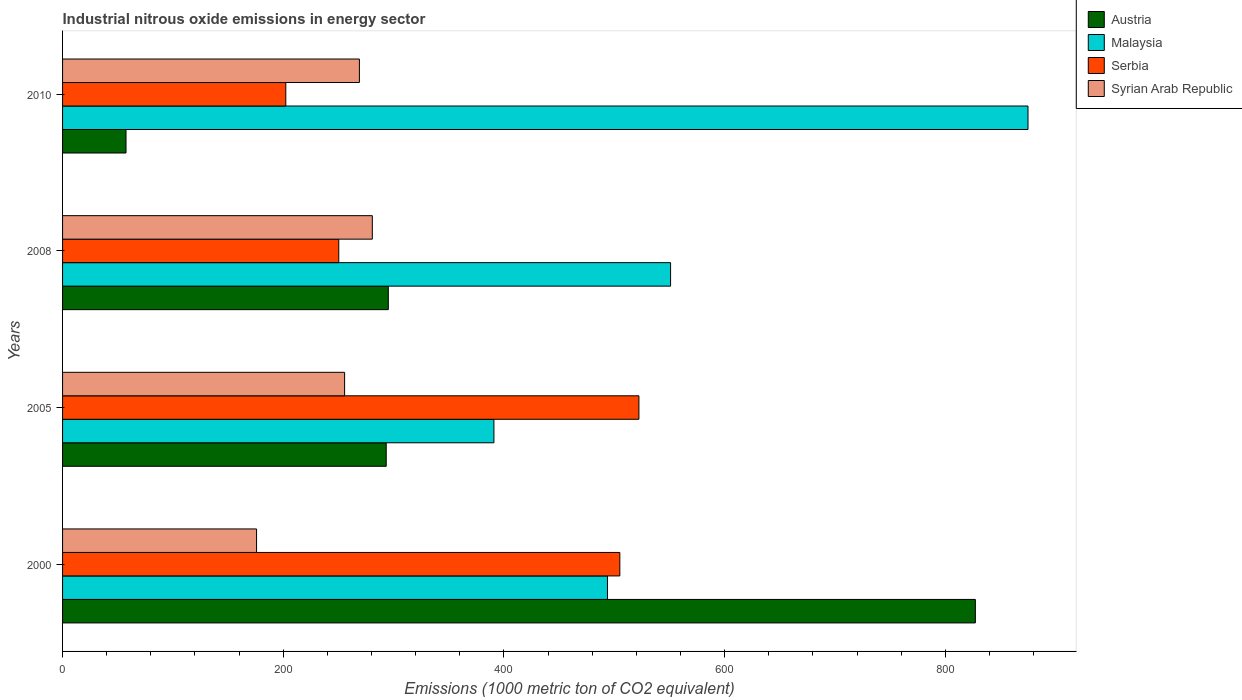How many different coloured bars are there?
Offer a terse response. 4. How many groups of bars are there?
Offer a terse response. 4. Are the number of bars on each tick of the Y-axis equal?
Your answer should be very brief. Yes. How many bars are there on the 4th tick from the top?
Provide a succinct answer. 4. What is the label of the 2nd group of bars from the top?
Offer a very short reply. 2008. In how many cases, is the number of bars for a given year not equal to the number of legend labels?
Your response must be concise. 0. What is the amount of industrial nitrous oxide emitted in Syrian Arab Republic in 2008?
Give a very brief answer. 280.7. Across all years, what is the maximum amount of industrial nitrous oxide emitted in Serbia?
Give a very brief answer. 522.3. Across all years, what is the minimum amount of industrial nitrous oxide emitted in Austria?
Give a very brief answer. 57.5. In which year was the amount of industrial nitrous oxide emitted in Syrian Arab Republic maximum?
Provide a succinct answer. 2008. In which year was the amount of industrial nitrous oxide emitted in Malaysia minimum?
Provide a short and direct response. 2005. What is the total amount of industrial nitrous oxide emitted in Serbia in the graph?
Provide a succinct answer. 1479.9. What is the difference between the amount of industrial nitrous oxide emitted in Malaysia in 2005 and that in 2008?
Keep it short and to the point. -160.1. What is the difference between the amount of industrial nitrous oxide emitted in Malaysia in 2000 and the amount of industrial nitrous oxide emitted in Syrian Arab Republic in 2008?
Offer a very short reply. 213.1. What is the average amount of industrial nitrous oxide emitted in Serbia per year?
Keep it short and to the point. 369.97. In the year 2000, what is the difference between the amount of industrial nitrous oxide emitted in Syrian Arab Republic and amount of industrial nitrous oxide emitted in Serbia?
Your answer should be very brief. -329.2. What is the ratio of the amount of industrial nitrous oxide emitted in Malaysia in 2005 to that in 2008?
Provide a short and direct response. 0.71. What is the difference between the highest and the second highest amount of industrial nitrous oxide emitted in Syrian Arab Republic?
Your answer should be compact. 11.7. What is the difference between the highest and the lowest amount of industrial nitrous oxide emitted in Syrian Arab Republic?
Provide a short and direct response. 104.9. In how many years, is the amount of industrial nitrous oxide emitted in Austria greater than the average amount of industrial nitrous oxide emitted in Austria taken over all years?
Offer a terse response. 1. What does the 2nd bar from the top in 2008 represents?
Ensure brevity in your answer.  Serbia. Is it the case that in every year, the sum of the amount of industrial nitrous oxide emitted in Austria and amount of industrial nitrous oxide emitted in Serbia is greater than the amount of industrial nitrous oxide emitted in Malaysia?
Offer a terse response. No. How many years are there in the graph?
Offer a very short reply. 4. What is the difference between two consecutive major ticks on the X-axis?
Your answer should be very brief. 200. Are the values on the major ticks of X-axis written in scientific E-notation?
Provide a succinct answer. No. Does the graph contain any zero values?
Provide a short and direct response. No. How are the legend labels stacked?
Keep it short and to the point. Vertical. What is the title of the graph?
Your answer should be compact. Industrial nitrous oxide emissions in energy sector. Does "Puerto Rico" appear as one of the legend labels in the graph?
Give a very brief answer. No. What is the label or title of the X-axis?
Make the answer very short. Emissions (1000 metric ton of CO2 equivalent). What is the Emissions (1000 metric ton of CO2 equivalent) in Austria in 2000?
Give a very brief answer. 827.2. What is the Emissions (1000 metric ton of CO2 equivalent) in Malaysia in 2000?
Your answer should be compact. 493.8. What is the Emissions (1000 metric ton of CO2 equivalent) in Serbia in 2000?
Provide a short and direct response. 505. What is the Emissions (1000 metric ton of CO2 equivalent) in Syrian Arab Republic in 2000?
Your answer should be compact. 175.8. What is the Emissions (1000 metric ton of CO2 equivalent) of Austria in 2005?
Keep it short and to the point. 293.3. What is the Emissions (1000 metric ton of CO2 equivalent) of Malaysia in 2005?
Your response must be concise. 390.9. What is the Emissions (1000 metric ton of CO2 equivalent) of Serbia in 2005?
Give a very brief answer. 522.3. What is the Emissions (1000 metric ton of CO2 equivalent) in Syrian Arab Republic in 2005?
Provide a succinct answer. 255.6. What is the Emissions (1000 metric ton of CO2 equivalent) of Austria in 2008?
Provide a succinct answer. 295.2. What is the Emissions (1000 metric ton of CO2 equivalent) of Malaysia in 2008?
Your answer should be very brief. 551. What is the Emissions (1000 metric ton of CO2 equivalent) of Serbia in 2008?
Your answer should be compact. 250.3. What is the Emissions (1000 metric ton of CO2 equivalent) in Syrian Arab Republic in 2008?
Keep it short and to the point. 280.7. What is the Emissions (1000 metric ton of CO2 equivalent) in Austria in 2010?
Your answer should be very brief. 57.5. What is the Emissions (1000 metric ton of CO2 equivalent) in Malaysia in 2010?
Provide a short and direct response. 874.9. What is the Emissions (1000 metric ton of CO2 equivalent) in Serbia in 2010?
Provide a short and direct response. 202.3. What is the Emissions (1000 metric ton of CO2 equivalent) of Syrian Arab Republic in 2010?
Your answer should be very brief. 269. Across all years, what is the maximum Emissions (1000 metric ton of CO2 equivalent) in Austria?
Give a very brief answer. 827.2. Across all years, what is the maximum Emissions (1000 metric ton of CO2 equivalent) of Malaysia?
Your answer should be very brief. 874.9. Across all years, what is the maximum Emissions (1000 metric ton of CO2 equivalent) of Serbia?
Ensure brevity in your answer.  522.3. Across all years, what is the maximum Emissions (1000 metric ton of CO2 equivalent) in Syrian Arab Republic?
Give a very brief answer. 280.7. Across all years, what is the minimum Emissions (1000 metric ton of CO2 equivalent) in Austria?
Make the answer very short. 57.5. Across all years, what is the minimum Emissions (1000 metric ton of CO2 equivalent) in Malaysia?
Provide a succinct answer. 390.9. Across all years, what is the minimum Emissions (1000 metric ton of CO2 equivalent) in Serbia?
Provide a short and direct response. 202.3. Across all years, what is the minimum Emissions (1000 metric ton of CO2 equivalent) in Syrian Arab Republic?
Provide a short and direct response. 175.8. What is the total Emissions (1000 metric ton of CO2 equivalent) of Austria in the graph?
Keep it short and to the point. 1473.2. What is the total Emissions (1000 metric ton of CO2 equivalent) in Malaysia in the graph?
Ensure brevity in your answer.  2310.6. What is the total Emissions (1000 metric ton of CO2 equivalent) in Serbia in the graph?
Provide a short and direct response. 1479.9. What is the total Emissions (1000 metric ton of CO2 equivalent) of Syrian Arab Republic in the graph?
Offer a very short reply. 981.1. What is the difference between the Emissions (1000 metric ton of CO2 equivalent) of Austria in 2000 and that in 2005?
Your answer should be compact. 533.9. What is the difference between the Emissions (1000 metric ton of CO2 equivalent) in Malaysia in 2000 and that in 2005?
Provide a short and direct response. 102.9. What is the difference between the Emissions (1000 metric ton of CO2 equivalent) of Serbia in 2000 and that in 2005?
Your answer should be very brief. -17.3. What is the difference between the Emissions (1000 metric ton of CO2 equivalent) in Syrian Arab Republic in 2000 and that in 2005?
Provide a succinct answer. -79.8. What is the difference between the Emissions (1000 metric ton of CO2 equivalent) in Austria in 2000 and that in 2008?
Offer a terse response. 532. What is the difference between the Emissions (1000 metric ton of CO2 equivalent) of Malaysia in 2000 and that in 2008?
Keep it short and to the point. -57.2. What is the difference between the Emissions (1000 metric ton of CO2 equivalent) in Serbia in 2000 and that in 2008?
Offer a terse response. 254.7. What is the difference between the Emissions (1000 metric ton of CO2 equivalent) in Syrian Arab Republic in 2000 and that in 2008?
Offer a terse response. -104.9. What is the difference between the Emissions (1000 metric ton of CO2 equivalent) in Austria in 2000 and that in 2010?
Provide a short and direct response. 769.7. What is the difference between the Emissions (1000 metric ton of CO2 equivalent) in Malaysia in 2000 and that in 2010?
Make the answer very short. -381.1. What is the difference between the Emissions (1000 metric ton of CO2 equivalent) of Serbia in 2000 and that in 2010?
Your answer should be compact. 302.7. What is the difference between the Emissions (1000 metric ton of CO2 equivalent) in Syrian Arab Republic in 2000 and that in 2010?
Your response must be concise. -93.2. What is the difference between the Emissions (1000 metric ton of CO2 equivalent) of Malaysia in 2005 and that in 2008?
Ensure brevity in your answer.  -160.1. What is the difference between the Emissions (1000 metric ton of CO2 equivalent) of Serbia in 2005 and that in 2008?
Provide a succinct answer. 272. What is the difference between the Emissions (1000 metric ton of CO2 equivalent) of Syrian Arab Republic in 2005 and that in 2008?
Provide a succinct answer. -25.1. What is the difference between the Emissions (1000 metric ton of CO2 equivalent) in Austria in 2005 and that in 2010?
Provide a short and direct response. 235.8. What is the difference between the Emissions (1000 metric ton of CO2 equivalent) of Malaysia in 2005 and that in 2010?
Ensure brevity in your answer.  -484. What is the difference between the Emissions (1000 metric ton of CO2 equivalent) of Serbia in 2005 and that in 2010?
Provide a succinct answer. 320. What is the difference between the Emissions (1000 metric ton of CO2 equivalent) of Austria in 2008 and that in 2010?
Keep it short and to the point. 237.7. What is the difference between the Emissions (1000 metric ton of CO2 equivalent) in Malaysia in 2008 and that in 2010?
Offer a terse response. -323.9. What is the difference between the Emissions (1000 metric ton of CO2 equivalent) in Syrian Arab Republic in 2008 and that in 2010?
Your response must be concise. 11.7. What is the difference between the Emissions (1000 metric ton of CO2 equivalent) of Austria in 2000 and the Emissions (1000 metric ton of CO2 equivalent) of Malaysia in 2005?
Offer a very short reply. 436.3. What is the difference between the Emissions (1000 metric ton of CO2 equivalent) in Austria in 2000 and the Emissions (1000 metric ton of CO2 equivalent) in Serbia in 2005?
Give a very brief answer. 304.9. What is the difference between the Emissions (1000 metric ton of CO2 equivalent) of Austria in 2000 and the Emissions (1000 metric ton of CO2 equivalent) of Syrian Arab Republic in 2005?
Keep it short and to the point. 571.6. What is the difference between the Emissions (1000 metric ton of CO2 equivalent) of Malaysia in 2000 and the Emissions (1000 metric ton of CO2 equivalent) of Serbia in 2005?
Provide a short and direct response. -28.5. What is the difference between the Emissions (1000 metric ton of CO2 equivalent) of Malaysia in 2000 and the Emissions (1000 metric ton of CO2 equivalent) of Syrian Arab Republic in 2005?
Your answer should be very brief. 238.2. What is the difference between the Emissions (1000 metric ton of CO2 equivalent) of Serbia in 2000 and the Emissions (1000 metric ton of CO2 equivalent) of Syrian Arab Republic in 2005?
Ensure brevity in your answer.  249.4. What is the difference between the Emissions (1000 metric ton of CO2 equivalent) of Austria in 2000 and the Emissions (1000 metric ton of CO2 equivalent) of Malaysia in 2008?
Provide a succinct answer. 276.2. What is the difference between the Emissions (1000 metric ton of CO2 equivalent) in Austria in 2000 and the Emissions (1000 metric ton of CO2 equivalent) in Serbia in 2008?
Offer a terse response. 576.9. What is the difference between the Emissions (1000 metric ton of CO2 equivalent) in Austria in 2000 and the Emissions (1000 metric ton of CO2 equivalent) in Syrian Arab Republic in 2008?
Your answer should be compact. 546.5. What is the difference between the Emissions (1000 metric ton of CO2 equivalent) in Malaysia in 2000 and the Emissions (1000 metric ton of CO2 equivalent) in Serbia in 2008?
Provide a short and direct response. 243.5. What is the difference between the Emissions (1000 metric ton of CO2 equivalent) in Malaysia in 2000 and the Emissions (1000 metric ton of CO2 equivalent) in Syrian Arab Republic in 2008?
Make the answer very short. 213.1. What is the difference between the Emissions (1000 metric ton of CO2 equivalent) in Serbia in 2000 and the Emissions (1000 metric ton of CO2 equivalent) in Syrian Arab Republic in 2008?
Provide a succinct answer. 224.3. What is the difference between the Emissions (1000 metric ton of CO2 equivalent) of Austria in 2000 and the Emissions (1000 metric ton of CO2 equivalent) of Malaysia in 2010?
Your response must be concise. -47.7. What is the difference between the Emissions (1000 metric ton of CO2 equivalent) in Austria in 2000 and the Emissions (1000 metric ton of CO2 equivalent) in Serbia in 2010?
Ensure brevity in your answer.  624.9. What is the difference between the Emissions (1000 metric ton of CO2 equivalent) of Austria in 2000 and the Emissions (1000 metric ton of CO2 equivalent) of Syrian Arab Republic in 2010?
Offer a terse response. 558.2. What is the difference between the Emissions (1000 metric ton of CO2 equivalent) in Malaysia in 2000 and the Emissions (1000 metric ton of CO2 equivalent) in Serbia in 2010?
Offer a very short reply. 291.5. What is the difference between the Emissions (1000 metric ton of CO2 equivalent) of Malaysia in 2000 and the Emissions (1000 metric ton of CO2 equivalent) of Syrian Arab Republic in 2010?
Keep it short and to the point. 224.8. What is the difference between the Emissions (1000 metric ton of CO2 equivalent) of Serbia in 2000 and the Emissions (1000 metric ton of CO2 equivalent) of Syrian Arab Republic in 2010?
Offer a terse response. 236. What is the difference between the Emissions (1000 metric ton of CO2 equivalent) of Austria in 2005 and the Emissions (1000 metric ton of CO2 equivalent) of Malaysia in 2008?
Your response must be concise. -257.7. What is the difference between the Emissions (1000 metric ton of CO2 equivalent) in Austria in 2005 and the Emissions (1000 metric ton of CO2 equivalent) in Syrian Arab Republic in 2008?
Provide a succinct answer. 12.6. What is the difference between the Emissions (1000 metric ton of CO2 equivalent) in Malaysia in 2005 and the Emissions (1000 metric ton of CO2 equivalent) in Serbia in 2008?
Make the answer very short. 140.6. What is the difference between the Emissions (1000 metric ton of CO2 equivalent) of Malaysia in 2005 and the Emissions (1000 metric ton of CO2 equivalent) of Syrian Arab Republic in 2008?
Provide a short and direct response. 110.2. What is the difference between the Emissions (1000 metric ton of CO2 equivalent) in Serbia in 2005 and the Emissions (1000 metric ton of CO2 equivalent) in Syrian Arab Republic in 2008?
Offer a terse response. 241.6. What is the difference between the Emissions (1000 metric ton of CO2 equivalent) of Austria in 2005 and the Emissions (1000 metric ton of CO2 equivalent) of Malaysia in 2010?
Offer a terse response. -581.6. What is the difference between the Emissions (1000 metric ton of CO2 equivalent) in Austria in 2005 and the Emissions (1000 metric ton of CO2 equivalent) in Serbia in 2010?
Your response must be concise. 91. What is the difference between the Emissions (1000 metric ton of CO2 equivalent) in Austria in 2005 and the Emissions (1000 metric ton of CO2 equivalent) in Syrian Arab Republic in 2010?
Give a very brief answer. 24.3. What is the difference between the Emissions (1000 metric ton of CO2 equivalent) in Malaysia in 2005 and the Emissions (1000 metric ton of CO2 equivalent) in Serbia in 2010?
Provide a short and direct response. 188.6. What is the difference between the Emissions (1000 metric ton of CO2 equivalent) in Malaysia in 2005 and the Emissions (1000 metric ton of CO2 equivalent) in Syrian Arab Republic in 2010?
Give a very brief answer. 121.9. What is the difference between the Emissions (1000 metric ton of CO2 equivalent) in Serbia in 2005 and the Emissions (1000 metric ton of CO2 equivalent) in Syrian Arab Republic in 2010?
Give a very brief answer. 253.3. What is the difference between the Emissions (1000 metric ton of CO2 equivalent) in Austria in 2008 and the Emissions (1000 metric ton of CO2 equivalent) in Malaysia in 2010?
Your response must be concise. -579.7. What is the difference between the Emissions (1000 metric ton of CO2 equivalent) of Austria in 2008 and the Emissions (1000 metric ton of CO2 equivalent) of Serbia in 2010?
Your answer should be compact. 92.9. What is the difference between the Emissions (1000 metric ton of CO2 equivalent) of Austria in 2008 and the Emissions (1000 metric ton of CO2 equivalent) of Syrian Arab Republic in 2010?
Make the answer very short. 26.2. What is the difference between the Emissions (1000 metric ton of CO2 equivalent) in Malaysia in 2008 and the Emissions (1000 metric ton of CO2 equivalent) in Serbia in 2010?
Your answer should be compact. 348.7. What is the difference between the Emissions (1000 metric ton of CO2 equivalent) of Malaysia in 2008 and the Emissions (1000 metric ton of CO2 equivalent) of Syrian Arab Republic in 2010?
Your response must be concise. 282. What is the difference between the Emissions (1000 metric ton of CO2 equivalent) of Serbia in 2008 and the Emissions (1000 metric ton of CO2 equivalent) of Syrian Arab Republic in 2010?
Provide a succinct answer. -18.7. What is the average Emissions (1000 metric ton of CO2 equivalent) of Austria per year?
Your answer should be very brief. 368.3. What is the average Emissions (1000 metric ton of CO2 equivalent) in Malaysia per year?
Ensure brevity in your answer.  577.65. What is the average Emissions (1000 metric ton of CO2 equivalent) in Serbia per year?
Keep it short and to the point. 369.98. What is the average Emissions (1000 metric ton of CO2 equivalent) in Syrian Arab Republic per year?
Ensure brevity in your answer.  245.28. In the year 2000, what is the difference between the Emissions (1000 metric ton of CO2 equivalent) of Austria and Emissions (1000 metric ton of CO2 equivalent) of Malaysia?
Provide a succinct answer. 333.4. In the year 2000, what is the difference between the Emissions (1000 metric ton of CO2 equivalent) in Austria and Emissions (1000 metric ton of CO2 equivalent) in Serbia?
Your response must be concise. 322.2. In the year 2000, what is the difference between the Emissions (1000 metric ton of CO2 equivalent) of Austria and Emissions (1000 metric ton of CO2 equivalent) of Syrian Arab Republic?
Your answer should be compact. 651.4. In the year 2000, what is the difference between the Emissions (1000 metric ton of CO2 equivalent) in Malaysia and Emissions (1000 metric ton of CO2 equivalent) in Syrian Arab Republic?
Provide a short and direct response. 318. In the year 2000, what is the difference between the Emissions (1000 metric ton of CO2 equivalent) in Serbia and Emissions (1000 metric ton of CO2 equivalent) in Syrian Arab Republic?
Make the answer very short. 329.2. In the year 2005, what is the difference between the Emissions (1000 metric ton of CO2 equivalent) of Austria and Emissions (1000 metric ton of CO2 equivalent) of Malaysia?
Provide a succinct answer. -97.6. In the year 2005, what is the difference between the Emissions (1000 metric ton of CO2 equivalent) in Austria and Emissions (1000 metric ton of CO2 equivalent) in Serbia?
Offer a very short reply. -229. In the year 2005, what is the difference between the Emissions (1000 metric ton of CO2 equivalent) in Austria and Emissions (1000 metric ton of CO2 equivalent) in Syrian Arab Republic?
Your response must be concise. 37.7. In the year 2005, what is the difference between the Emissions (1000 metric ton of CO2 equivalent) in Malaysia and Emissions (1000 metric ton of CO2 equivalent) in Serbia?
Provide a short and direct response. -131.4. In the year 2005, what is the difference between the Emissions (1000 metric ton of CO2 equivalent) in Malaysia and Emissions (1000 metric ton of CO2 equivalent) in Syrian Arab Republic?
Keep it short and to the point. 135.3. In the year 2005, what is the difference between the Emissions (1000 metric ton of CO2 equivalent) in Serbia and Emissions (1000 metric ton of CO2 equivalent) in Syrian Arab Republic?
Offer a terse response. 266.7. In the year 2008, what is the difference between the Emissions (1000 metric ton of CO2 equivalent) in Austria and Emissions (1000 metric ton of CO2 equivalent) in Malaysia?
Your response must be concise. -255.8. In the year 2008, what is the difference between the Emissions (1000 metric ton of CO2 equivalent) of Austria and Emissions (1000 metric ton of CO2 equivalent) of Serbia?
Offer a terse response. 44.9. In the year 2008, what is the difference between the Emissions (1000 metric ton of CO2 equivalent) of Malaysia and Emissions (1000 metric ton of CO2 equivalent) of Serbia?
Your response must be concise. 300.7. In the year 2008, what is the difference between the Emissions (1000 metric ton of CO2 equivalent) in Malaysia and Emissions (1000 metric ton of CO2 equivalent) in Syrian Arab Republic?
Make the answer very short. 270.3. In the year 2008, what is the difference between the Emissions (1000 metric ton of CO2 equivalent) in Serbia and Emissions (1000 metric ton of CO2 equivalent) in Syrian Arab Republic?
Provide a succinct answer. -30.4. In the year 2010, what is the difference between the Emissions (1000 metric ton of CO2 equivalent) in Austria and Emissions (1000 metric ton of CO2 equivalent) in Malaysia?
Ensure brevity in your answer.  -817.4. In the year 2010, what is the difference between the Emissions (1000 metric ton of CO2 equivalent) of Austria and Emissions (1000 metric ton of CO2 equivalent) of Serbia?
Provide a short and direct response. -144.8. In the year 2010, what is the difference between the Emissions (1000 metric ton of CO2 equivalent) of Austria and Emissions (1000 metric ton of CO2 equivalent) of Syrian Arab Republic?
Give a very brief answer. -211.5. In the year 2010, what is the difference between the Emissions (1000 metric ton of CO2 equivalent) of Malaysia and Emissions (1000 metric ton of CO2 equivalent) of Serbia?
Make the answer very short. 672.6. In the year 2010, what is the difference between the Emissions (1000 metric ton of CO2 equivalent) of Malaysia and Emissions (1000 metric ton of CO2 equivalent) of Syrian Arab Republic?
Provide a succinct answer. 605.9. In the year 2010, what is the difference between the Emissions (1000 metric ton of CO2 equivalent) of Serbia and Emissions (1000 metric ton of CO2 equivalent) of Syrian Arab Republic?
Make the answer very short. -66.7. What is the ratio of the Emissions (1000 metric ton of CO2 equivalent) of Austria in 2000 to that in 2005?
Give a very brief answer. 2.82. What is the ratio of the Emissions (1000 metric ton of CO2 equivalent) in Malaysia in 2000 to that in 2005?
Provide a short and direct response. 1.26. What is the ratio of the Emissions (1000 metric ton of CO2 equivalent) in Serbia in 2000 to that in 2005?
Give a very brief answer. 0.97. What is the ratio of the Emissions (1000 metric ton of CO2 equivalent) in Syrian Arab Republic in 2000 to that in 2005?
Provide a short and direct response. 0.69. What is the ratio of the Emissions (1000 metric ton of CO2 equivalent) of Austria in 2000 to that in 2008?
Make the answer very short. 2.8. What is the ratio of the Emissions (1000 metric ton of CO2 equivalent) of Malaysia in 2000 to that in 2008?
Your answer should be very brief. 0.9. What is the ratio of the Emissions (1000 metric ton of CO2 equivalent) of Serbia in 2000 to that in 2008?
Give a very brief answer. 2.02. What is the ratio of the Emissions (1000 metric ton of CO2 equivalent) of Syrian Arab Republic in 2000 to that in 2008?
Make the answer very short. 0.63. What is the ratio of the Emissions (1000 metric ton of CO2 equivalent) in Austria in 2000 to that in 2010?
Provide a succinct answer. 14.39. What is the ratio of the Emissions (1000 metric ton of CO2 equivalent) in Malaysia in 2000 to that in 2010?
Keep it short and to the point. 0.56. What is the ratio of the Emissions (1000 metric ton of CO2 equivalent) in Serbia in 2000 to that in 2010?
Give a very brief answer. 2.5. What is the ratio of the Emissions (1000 metric ton of CO2 equivalent) in Syrian Arab Republic in 2000 to that in 2010?
Provide a short and direct response. 0.65. What is the ratio of the Emissions (1000 metric ton of CO2 equivalent) of Austria in 2005 to that in 2008?
Give a very brief answer. 0.99. What is the ratio of the Emissions (1000 metric ton of CO2 equivalent) of Malaysia in 2005 to that in 2008?
Offer a very short reply. 0.71. What is the ratio of the Emissions (1000 metric ton of CO2 equivalent) of Serbia in 2005 to that in 2008?
Offer a very short reply. 2.09. What is the ratio of the Emissions (1000 metric ton of CO2 equivalent) of Syrian Arab Republic in 2005 to that in 2008?
Ensure brevity in your answer.  0.91. What is the ratio of the Emissions (1000 metric ton of CO2 equivalent) in Austria in 2005 to that in 2010?
Ensure brevity in your answer.  5.1. What is the ratio of the Emissions (1000 metric ton of CO2 equivalent) in Malaysia in 2005 to that in 2010?
Give a very brief answer. 0.45. What is the ratio of the Emissions (1000 metric ton of CO2 equivalent) in Serbia in 2005 to that in 2010?
Provide a succinct answer. 2.58. What is the ratio of the Emissions (1000 metric ton of CO2 equivalent) of Syrian Arab Republic in 2005 to that in 2010?
Your answer should be compact. 0.95. What is the ratio of the Emissions (1000 metric ton of CO2 equivalent) of Austria in 2008 to that in 2010?
Keep it short and to the point. 5.13. What is the ratio of the Emissions (1000 metric ton of CO2 equivalent) of Malaysia in 2008 to that in 2010?
Your response must be concise. 0.63. What is the ratio of the Emissions (1000 metric ton of CO2 equivalent) in Serbia in 2008 to that in 2010?
Provide a succinct answer. 1.24. What is the ratio of the Emissions (1000 metric ton of CO2 equivalent) of Syrian Arab Republic in 2008 to that in 2010?
Provide a succinct answer. 1.04. What is the difference between the highest and the second highest Emissions (1000 metric ton of CO2 equivalent) in Austria?
Offer a very short reply. 532. What is the difference between the highest and the second highest Emissions (1000 metric ton of CO2 equivalent) in Malaysia?
Ensure brevity in your answer.  323.9. What is the difference between the highest and the second highest Emissions (1000 metric ton of CO2 equivalent) of Serbia?
Offer a terse response. 17.3. What is the difference between the highest and the lowest Emissions (1000 metric ton of CO2 equivalent) in Austria?
Keep it short and to the point. 769.7. What is the difference between the highest and the lowest Emissions (1000 metric ton of CO2 equivalent) of Malaysia?
Your response must be concise. 484. What is the difference between the highest and the lowest Emissions (1000 metric ton of CO2 equivalent) of Serbia?
Give a very brief answer. 320. What is the difference between the highest and the lowest Emissions (1000 metric ton of CO2 equivalent) of Syrian Arab Republic?
Provide a short and direct response. 104.9. 